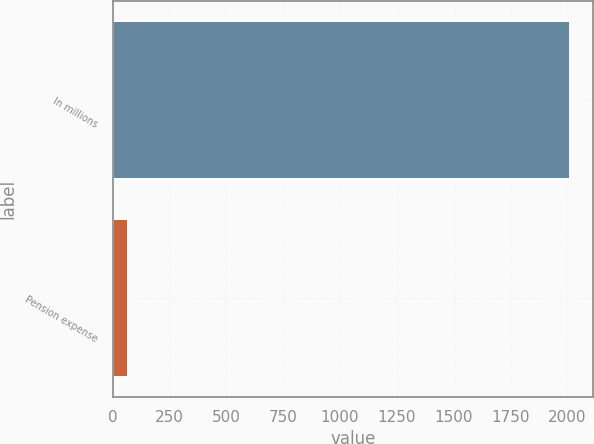<chart> <loc_0><loc_0><loc_500><loc_500><bar_chart><fcel>In millions<fcel>Pension expense<nl><fcel>2012<fcel>68<nl></chart> 